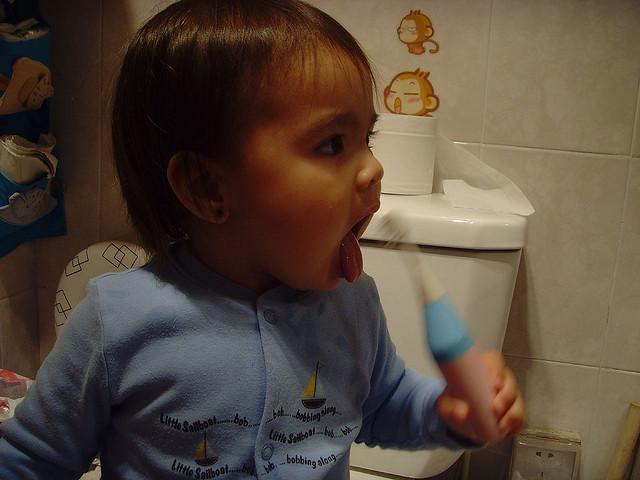How many snaps are on the child's shirt?
Give a very brief answer. 2. How many laptops are there?
Give a very brief answer. 0. 